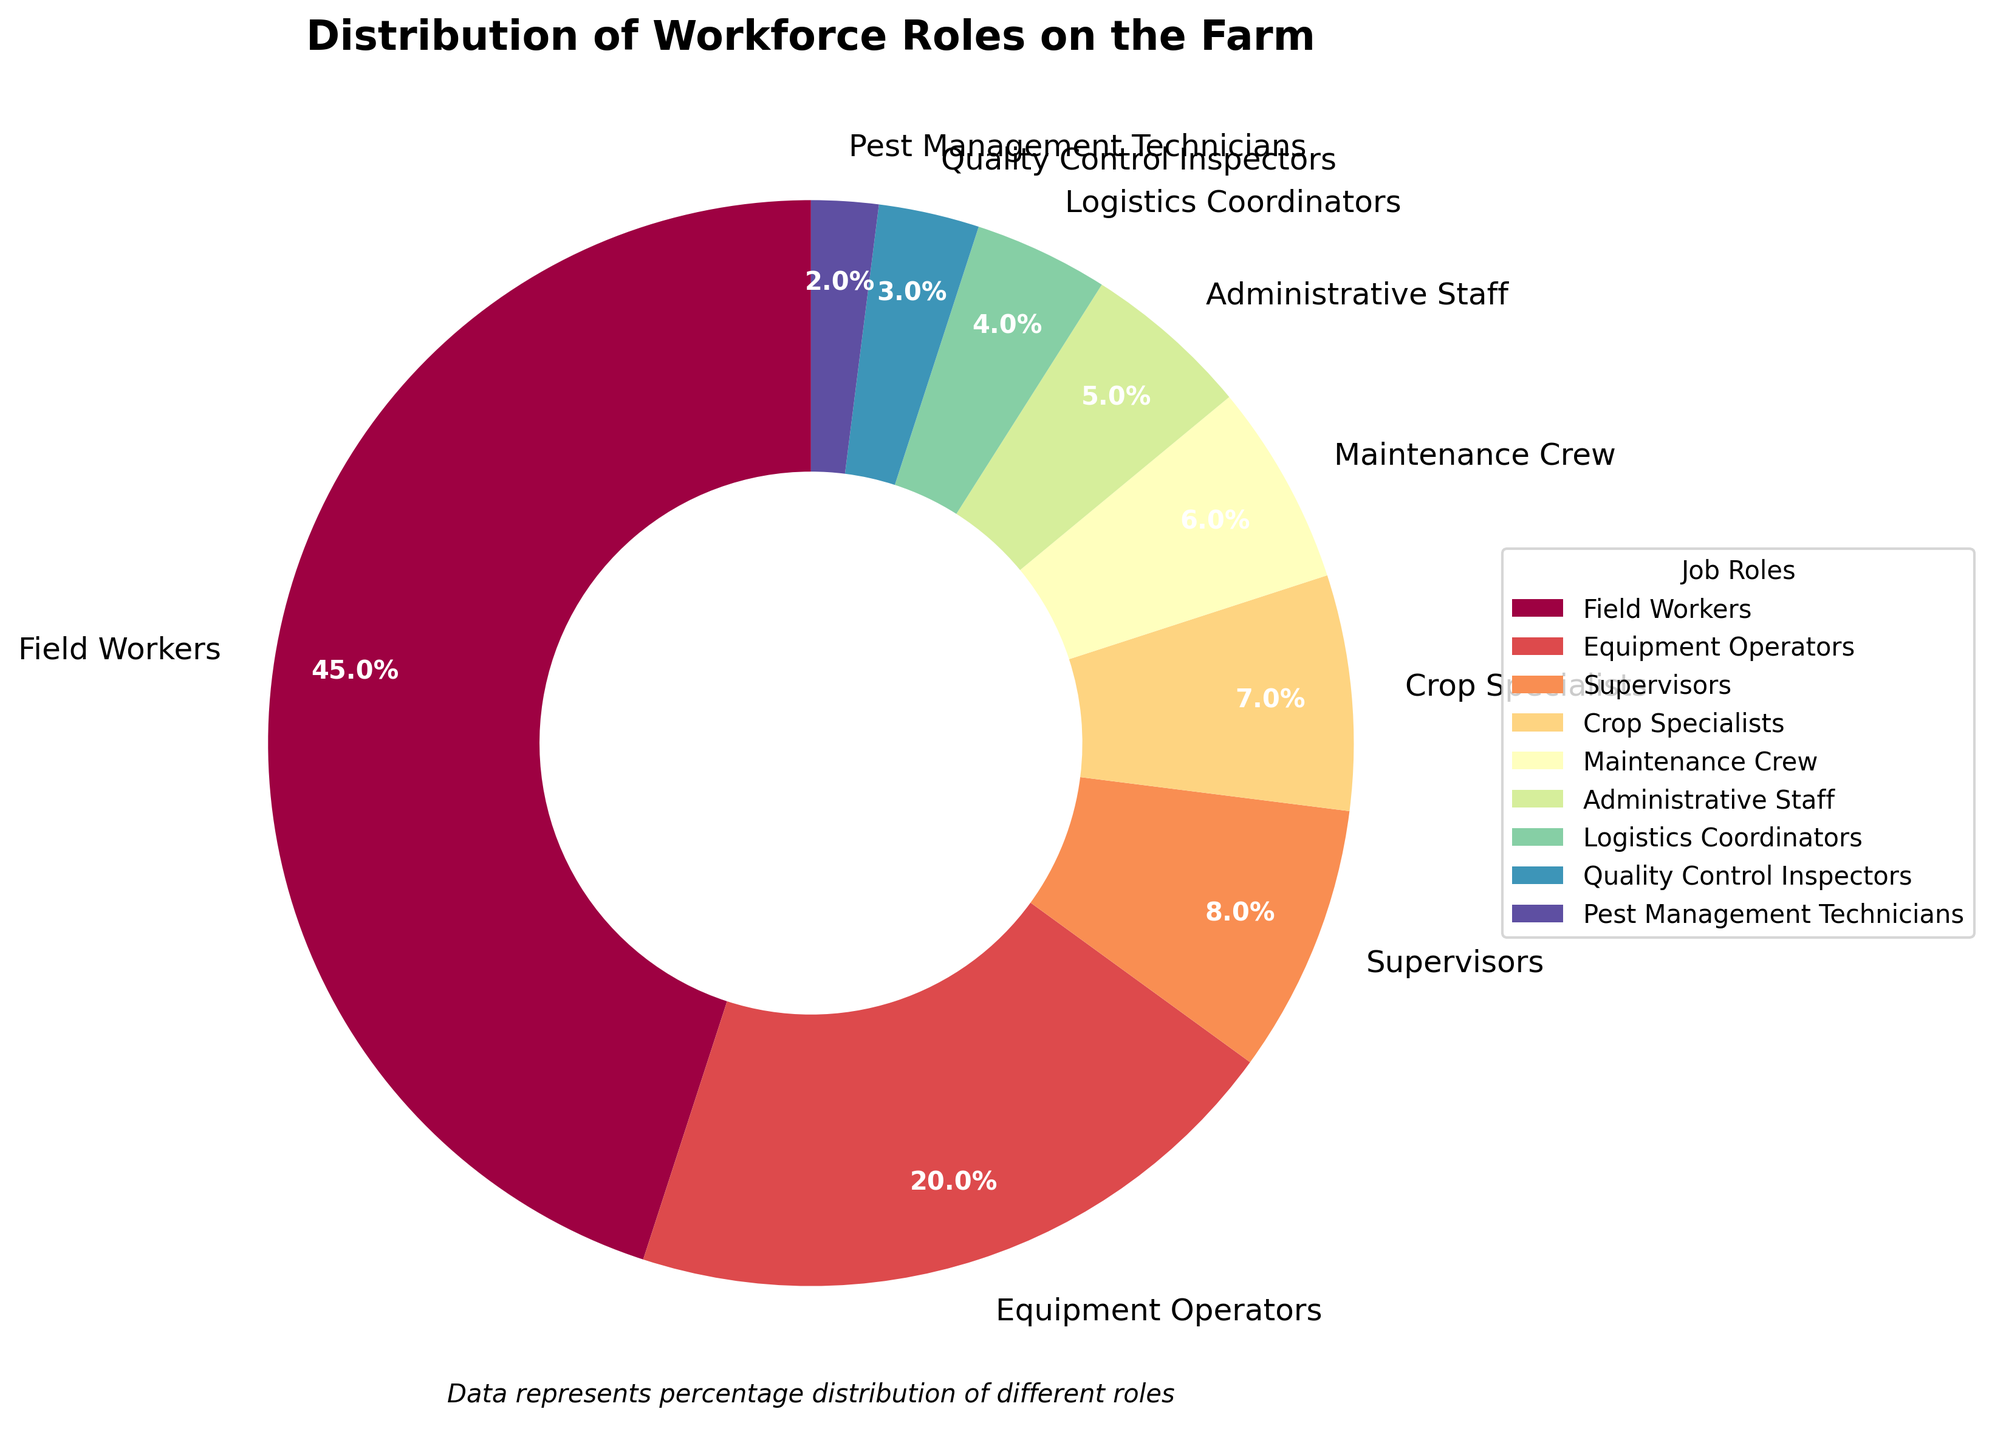Which job role has the highest percentage in the workforce? The pie chart shows that Field Workers take up the largest portion of the overall pie, indicating that they have the highest percentage.
Answer: Field Workers How many job roles have a percentage less than or equal to 5%? By looking at the pie chart, we can see Administrative Staff, Logistics Coordinators, Quality Control Inspectors, and Pest Management Technicians each have 5% or less. This totals to four job roles.
Answer: 4 What is the combined percentage of Equipment Operators and Supervisors? The pie chart indicates Equipment Operators have 20% and Supervisors have 8%. Adding these together gives 20% + 8% = 28%.
Answer: 28% Which job role has a smaller percentage, Crop Specialists or Maintenance Crew? By comparing their respective sections in the pie chart, it’s clear that Crop Specialists have a slightly smaller section compared to Maintenance Crew.
Answer: Crop Specialists What is the percentage difference between Field Workers and Administrative Staff? Field Workers have 45%, and Administrative Staff have 5%. The difference is 45% - 5% = 40%.
Answer: 40% Is the percentage of Quality Control Inspectors greater or less than that of Logistics Coordinators? The chart shows that Quality Control Inspectors have 3%, while Logistics Coordinators have 4%. Quality Control Inspectors have a smaller percentage.
Answer: Less What is the combined percentage of all job roles that have a percentage greater than 10%? Only Field Workers and Equipment Operators have percentages greater than 10% (45% and 20% respectively). Adding these gives 45% + 20% = 65%.
Answer: 65% Do Maintenance Crew and Administrative Staff together make up more than 10% of the workforce? Maintenance Crew has 6% and Administrative Staff has 5%. Combined, they are 6% + 5% = 11%, which is more than 10%.
Answer: Yes What is the average percentage of the three roles with the lowest percentages? The three roles with the lowest percentages are Quality Control Inspectors (3%), Pest Management Technicians (2%), and Logistics Coordinators (4%). Their average is (3% + 2% + 4%) / 3 = 9% / 3 = 3%.
Answer: 3% 